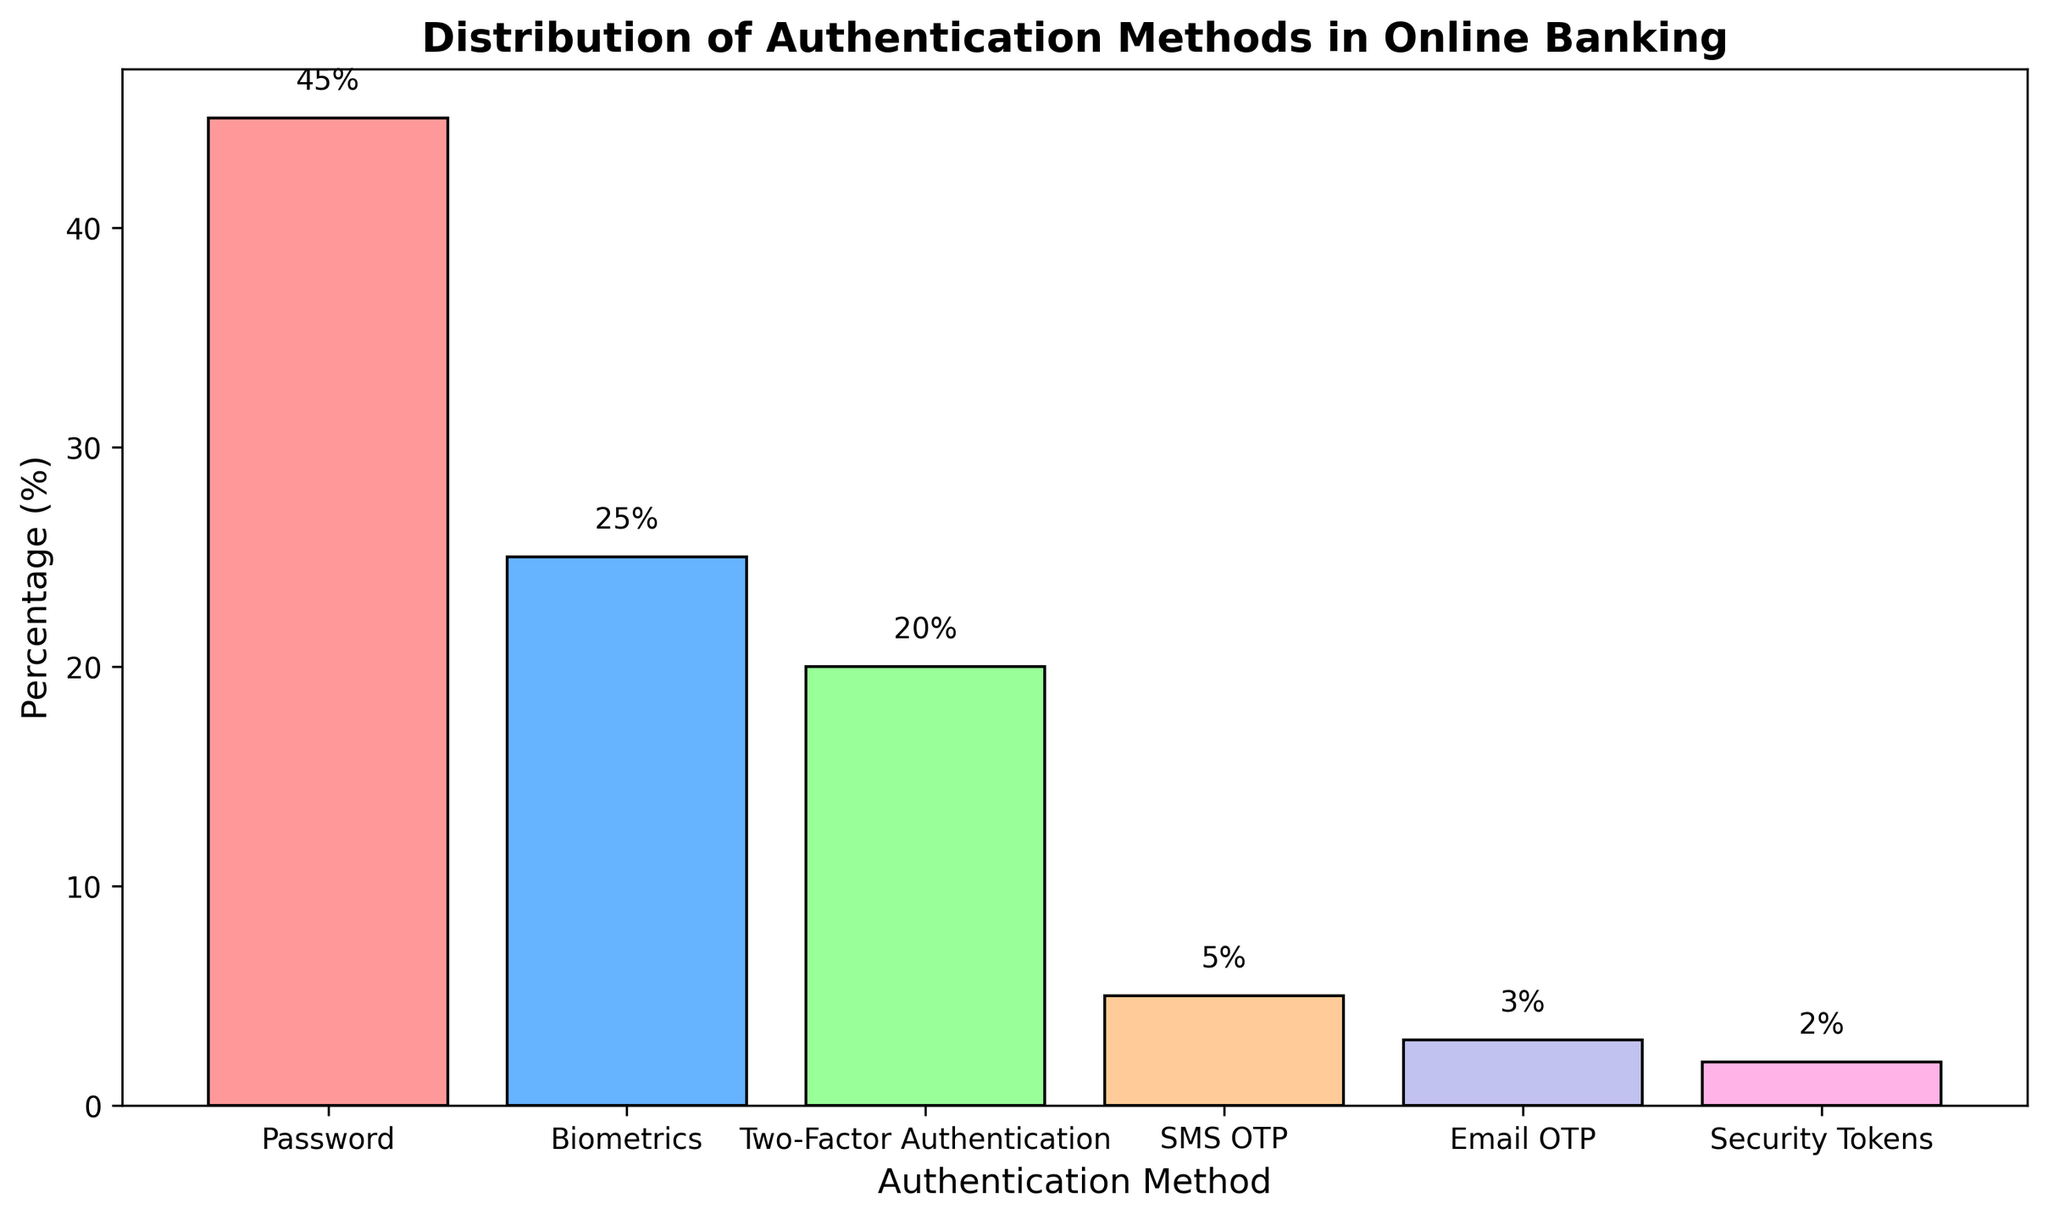Which authentication method is used the most in online banking? The height of the bar representing 'Password' is the tallest compared to the others, indicating it has the highest percentage.
Answer: Password Which authentication method is the least used? The shortest bar represents 'Security Tokens,' indicating it has the smallest percentage.
Answer: Security Tokens How many authentication methods have a percentage greater than 10%? The bars for 'Password,' 'Biometrics,' and 'Two-Factor Authentication' are all above the 10% mark. Counting these bars gives a total of three.
Answer: 3 What's the total percentage of the combined methods of Biometrics and Two-Factor Authentication? The percentage for Biometrics is 25% and for Two-Factor Authentication is 20%. Adding these together: 25 + 20 = 45%.
Answer: 45% Which two authentication methods have the smallest usage, and what is their combined percentage? The smallest bars belong to 'Security Tokens' and 'Email OTP,' with percentages of 2% and 3%, respectively. Their combined percentage is 2 + 3 = 5%.
Answer: Security Tokens and Email OTP, 5% What's the difference in usage percentage between Password and SMS OTP? The percentage for Password is 45% and for SMS OTP is 5%. The difference is 45 - 5 = 40%.
Answer: 40% Rank the authentication methods from most used to least used. The bars from tallest to shortest represent the ranking: Password, Biometrics, Two-Factor Authentication, SMS OTP, Email OTP, Security Tokens.
Answer: Password, Biometrics, Two-Factor Authentication, SMS OTP, Email OTP, Security Tokens What is the average percentage of the four least used methods? The percentages for SMS OTP, Email OTP, and Security Tokens are 5%, 3%, and 2%. Their sum is 5 + 3 + 2 = 10. Dividing by 4 to get the average: 10 / 4 = 2.5%.
Answer: 2.5% What is the median percentage value of the authentication methods? Sorting the percentages: 2%, 3%, 5%, 20%, 25%, 45%. The median, for an even number of data points, is the average of the two middle values: (5% + 20%) / 2 = 12.5%.
Answer: 12.5% What’s the percentage difference between the two most popular methods? The top two methods are Password (45%) and Biometrics (25%). The difference is 45 - 25 = 20%.
Answer: 20% 